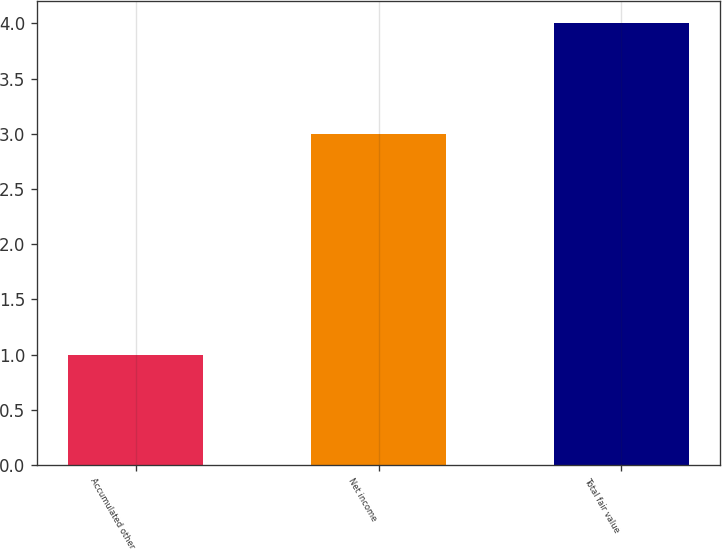<chart> <loc_0><loc_0><loc_500><loc_500><bar_chart><fcel>Accumulated other<fcel>Net income<fcel>Total fair value<nl><fcel>1<fcel>3<fcel>4<nl></chart> 